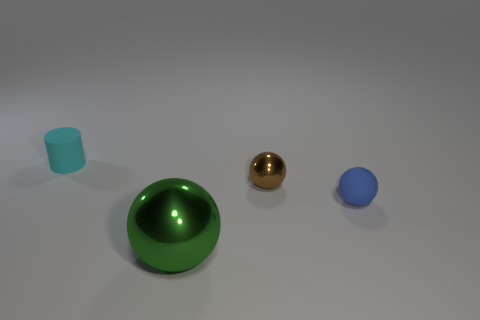How would you describe the setting of this collection of objects? The objects are arranged on a flat, even surface that resembles a neutral, non-descript studio environment. The lighting is soft and diffused, with shadows indicating a single overhead light source that brings emphasis to the objects' shapes and textures. 